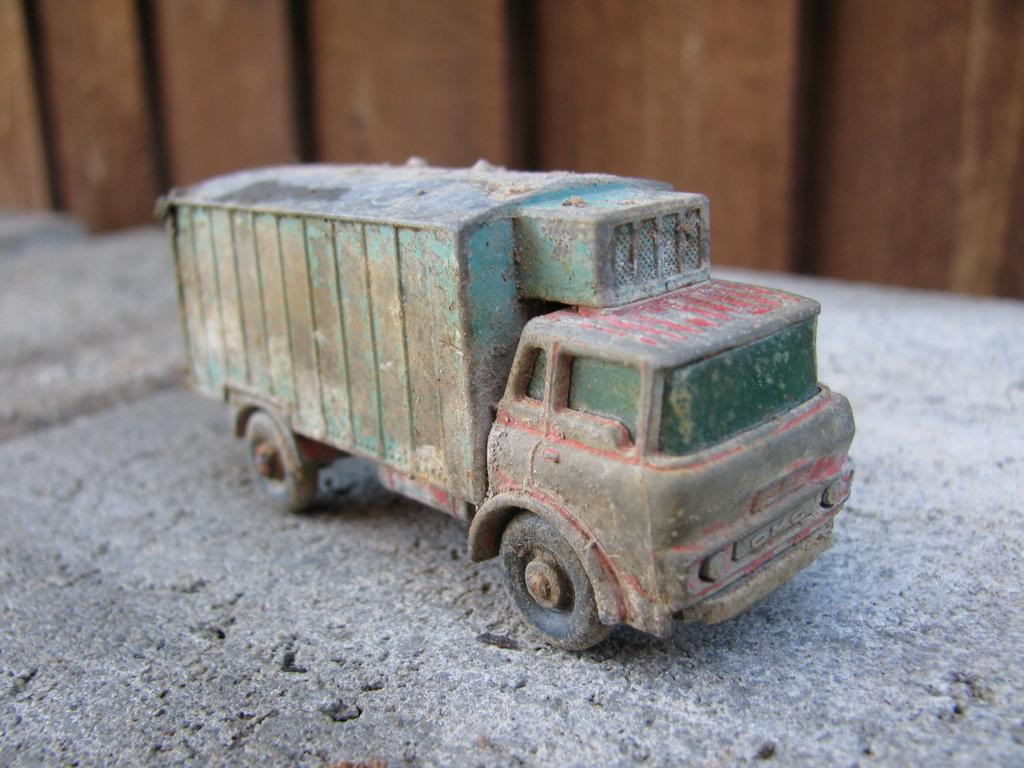What is the main subject of the image? There is a toy vehicle in the image. Where is the toy vehicle located in the image? The toy vehicle is in the front of the image. What can be seen in the background of the image? There is an object in the background of the image. What is the color of the object in the background? The object in the background is brown in color. Can you see the approval stamp on the receipt in the image? There is no receipt or approval stamp present in the image. 